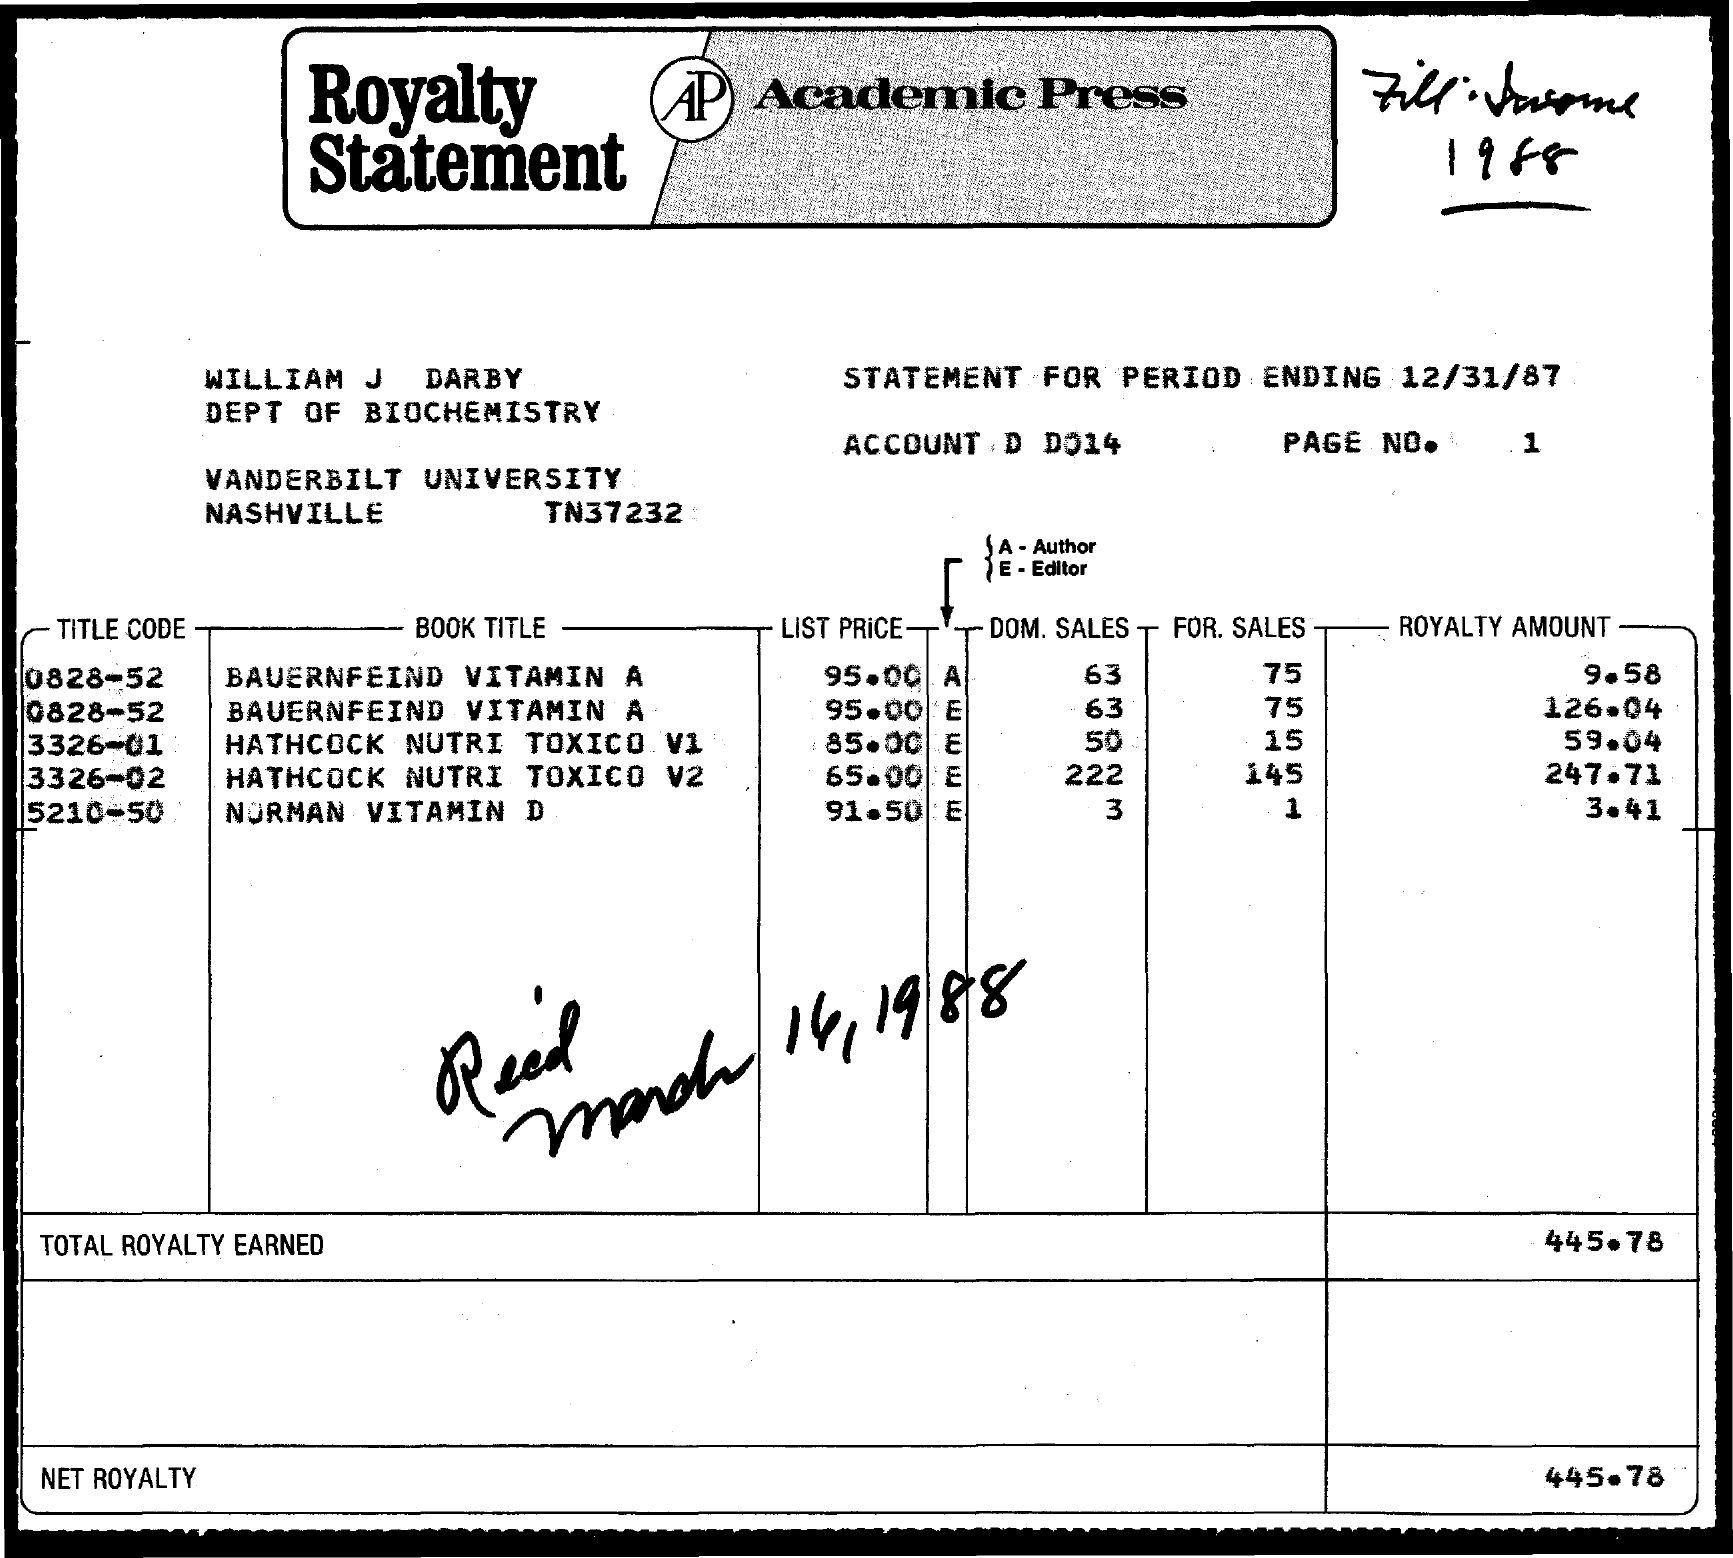What is the Book Title for title code 0828-52?
Your answer should be very brief. Bauernfeind Vitamin A. What is the List price for title code 0828-52?
Your response must be concise. 95.00. What is the DOM.SALES for title code 0828-52?
Provide a succinct answer. 63. What is the For. Sales for title code 0828-52?
Give a very brief answer. 75. What is the Book Title for title code 5210-50?
Keep it short and to the point. Norman Vitamin D. What is the Royalty amount for title code 5210-50?
Offer a very short reply. 3.41. What is the List Price for title code 5210-50?
Keep it short and to the point. 91.50. What is the Dom. Sales for title code 5210-50?
Ensure brevity in your answer.  3. What is the Net Royalty?
Offer a terse response. 445.78. 